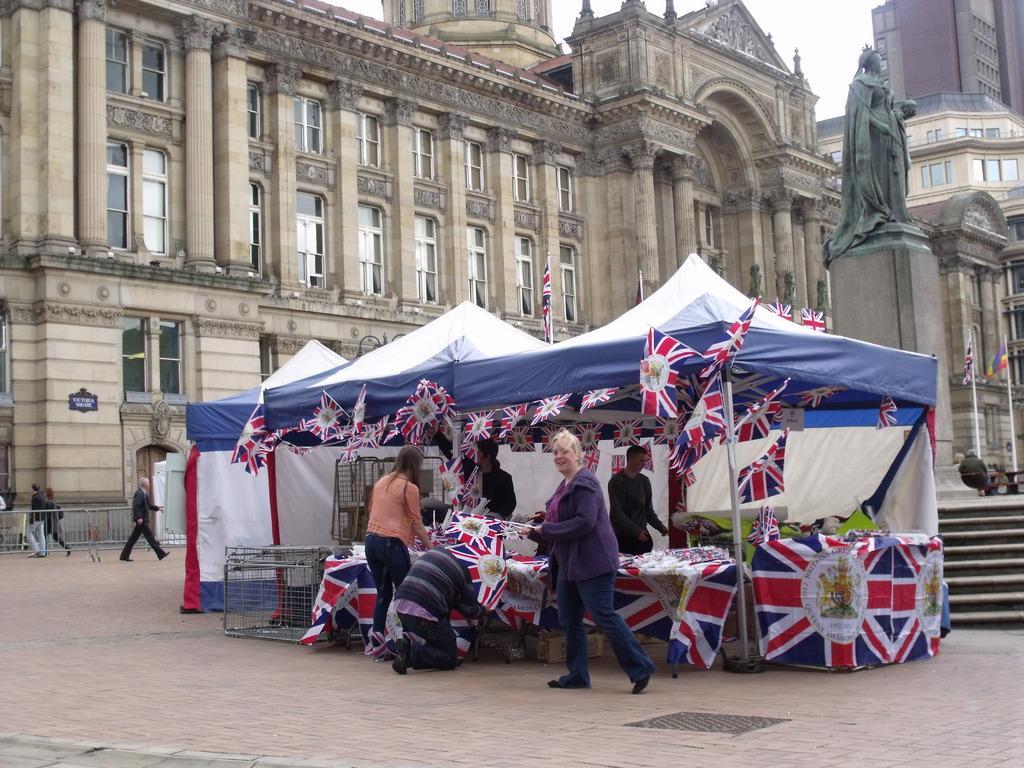Could you give a brief overview of what you see in this image? In this picture we can see people,tent,flags and in the background we can see a statue,buildings. 